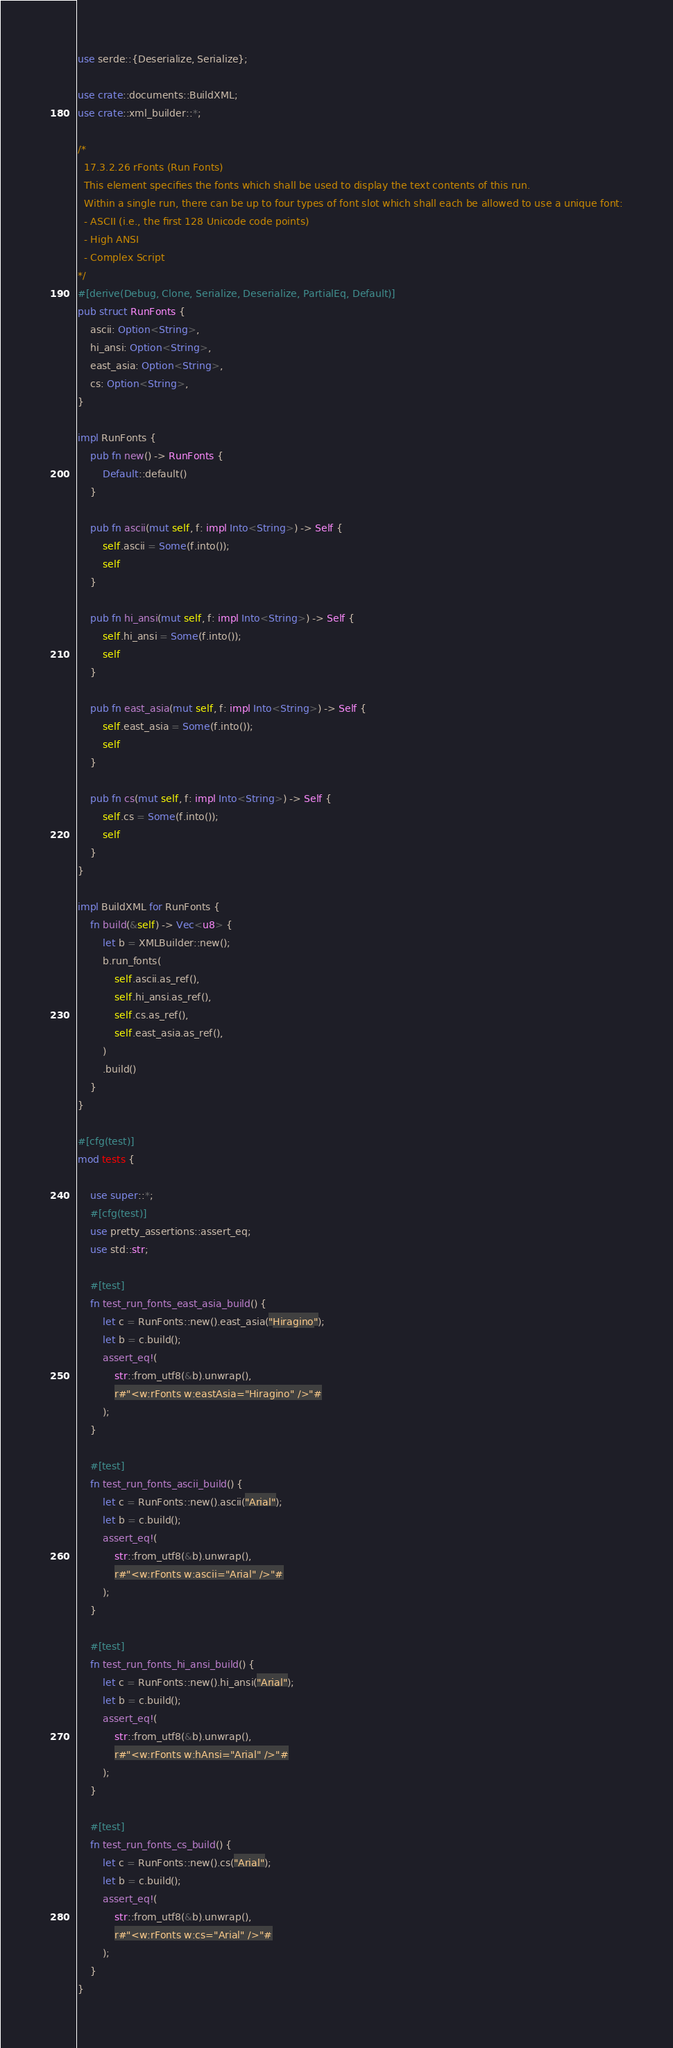Convert code to text. <code><loc_0><loc_0><loc_500><loc_500><_Rust_>use serde::{Deserialize, Serialize};

use crate::documents::BuildXML;
use crate::xml_builder::*;

/*
  17.3.2.26 rFonts (Run Fonts)
  This element specifies the fonts which shall be used to display the text contents of this run.
  Within a single run, there can be up to four types of font slot which shall each be allowed to use a unique font:
  - ASCII (i.e., the first 128 Unicode code points)
  - High ANSI
  - Complex Script
*/
#[derive(Debug, Clone, Serialize, Deserialize, PartialEq, Default)]
pub struct RunFonts {
    ascii: Option<String>,
    hi_ansi: Option<String>,
    east_asia: Option<String>,
    cs: Option<String>,
}

impl RunFonts {
    pub fn new() -> RunFonts {
        Default::default()
    }

    pub fn ascii(mut self, f: impl Into<String>) -> Self {
        self.ascii = Some(f.into());
        self
    }

    pub fn hi_ansi(mut self, f: impl Into<String>) -> Self {
        self.hi_ansi = Some(f.into());
        self
    }

    pub fn east_asia(mut self, f: impl Into<String>) -> Self {
        self.east_asia = Some(f.into());
        self
    }

    pub fn cs(mut self, f: impl Into<String>) -> Self {
        self.cs = Some(f.into());
        self
    }
}

impl BuildXML for RunFonts {
    fn build(&self) -> Vec<u8> {
        let b = XMLBuilder::new();
        b.run_fonts(
            self.ascii.as_ref(),
            self.hi_ansi.as_ref(),
            self.cs.as_ref(),
            self.east_asia.as_ref(),
        )
        .build()
    }
}

#[cfg(test)]
mod tests {

    use super::*;
    #[cfg(test)]
    use pretty_assertions::assert_eq;
    use std::str;

    #[test]
    fn test_run_fonts_east_asia_build() {
        let c = RunFonts::new().east_asia("Hiragino");
        let b = c.build();
        assert_eq!(
            str::from_utf8(&b).unwrap(),
            r#"<w:rFonts w:eastAsia="Hiragino" />"#
        );
    }

    #[test]
    fn test_run_fonts_ascii_build() {
        let c = RunFonts::new().ascii("Arial");
        let b = c.build();
        assert_eq!(
            str::from_utf8(&b).unwrap(),
            r#"<w:rFonts w:ascii="Arial" />"#
        );
    }

    #[test]
    fn test_run_fonts_hi_ansi_build() {
        let c = RunFonts::new().hi_ansi("Arial");
        let b = c.build();
        assert_eq!(
            str::from_utf8(&b).unwrap(),
            r#"<w:rFonts w:hAnsi="Arial" />"#
        );
    }

    #[test]
    fn test_run_fonts_cs_build() {
        let c = RunFonts::new().cs("Arial");
        let b = c.build();
        assert_eq!(
            str::from_utf8(&b).unwrap(),
            r#"<w:rFonts w:cs="Arial" />"#
        );
    }
}
</code> 